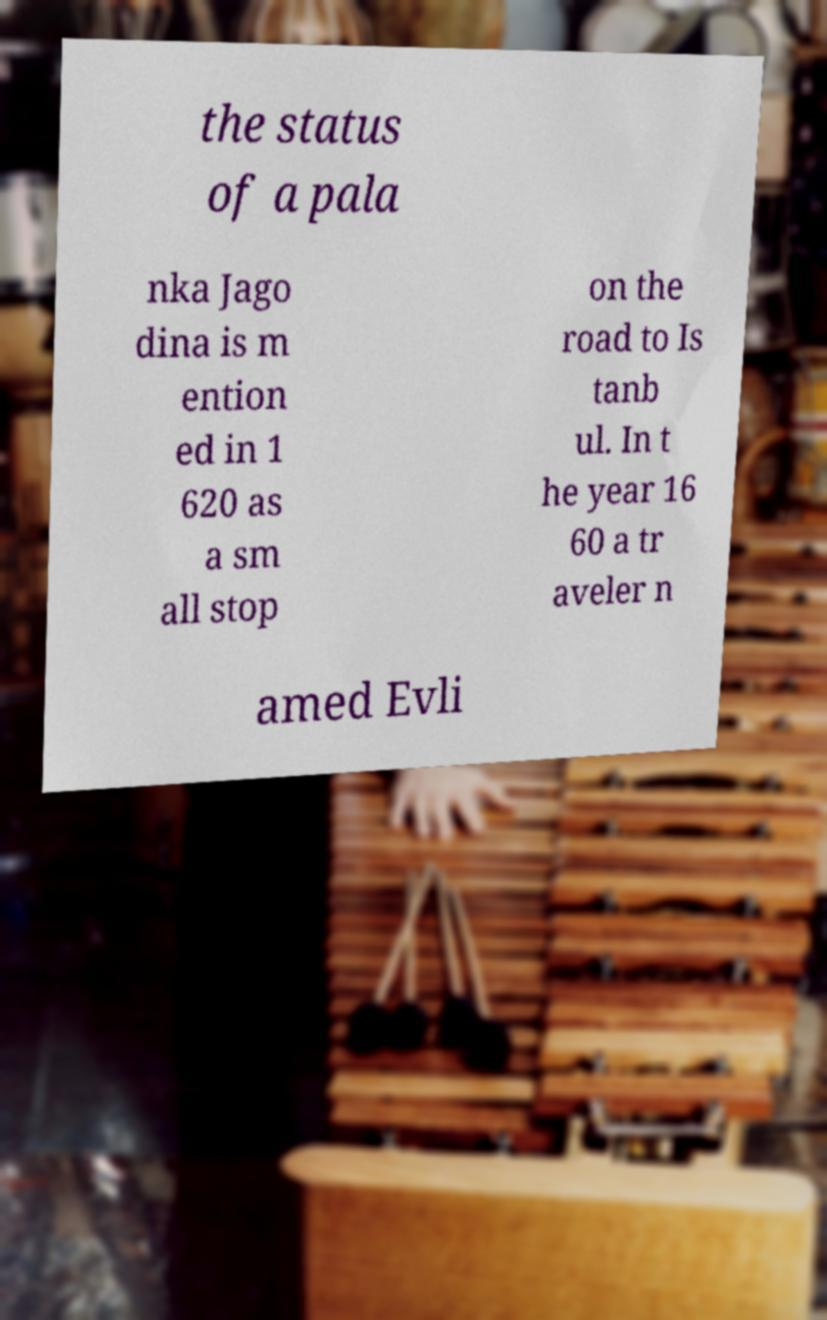What messages or text are displayed in this image? I need them in a readable, typed format. the status of a pala nka Jago dina is m ention ed in 1 620 as a sm all stop on the road to Is tanb ul. In t he year 16 60 a tr aveler n amed Evli 